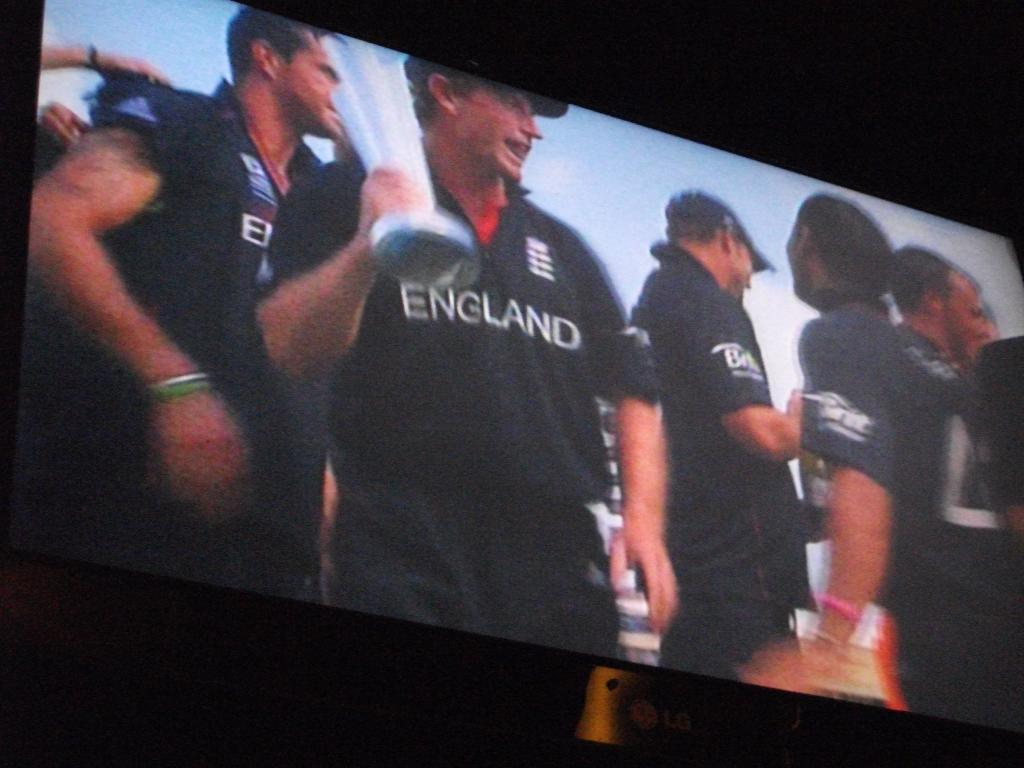<image>
Describe the image concisely. screen showing several men wearing blue shirts with england on front and one of them holding a trophy 